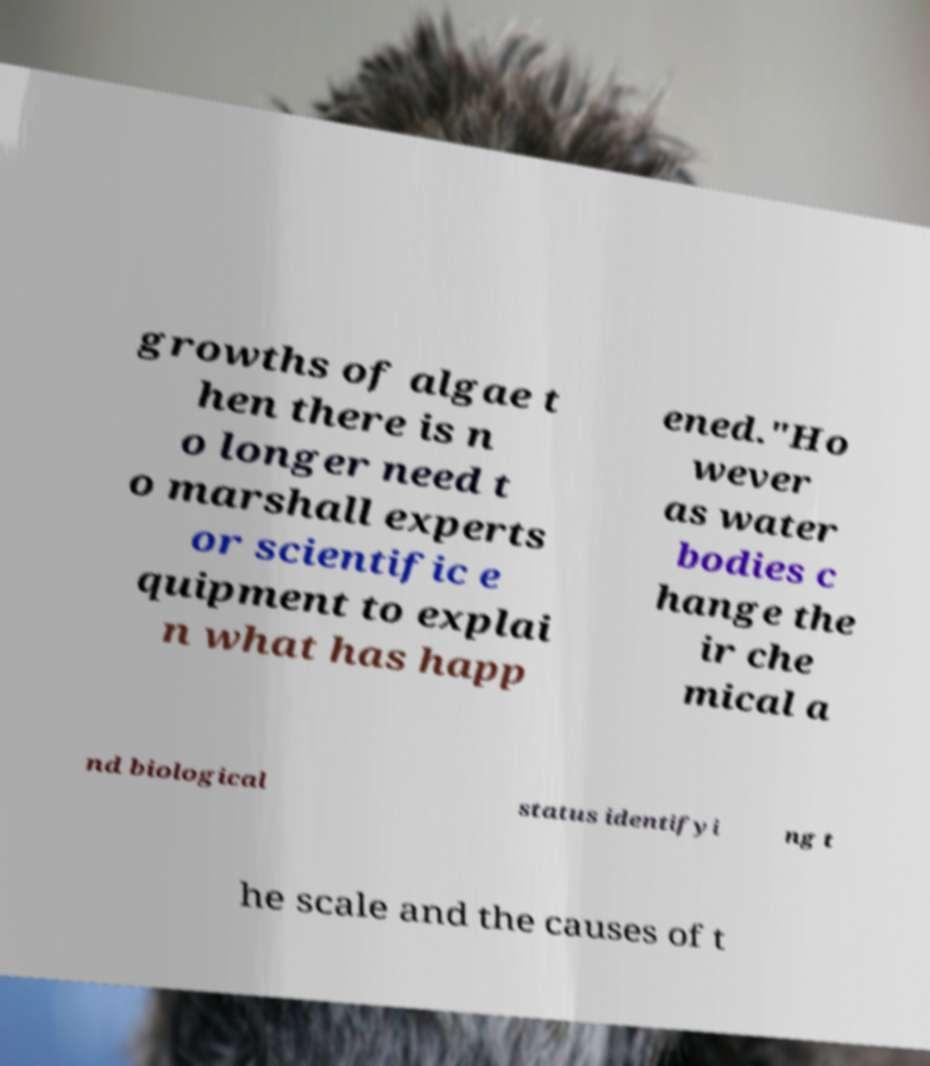Please identify and transcribe the text found in this image. growths of algae t hen there is n o longer need t o marshall experts or scientific e quipment to explai n what has happ ened."Ho wever as water bodies c hange the ir che mical a nd biological status identifyi ng t he scale and the causes of t 